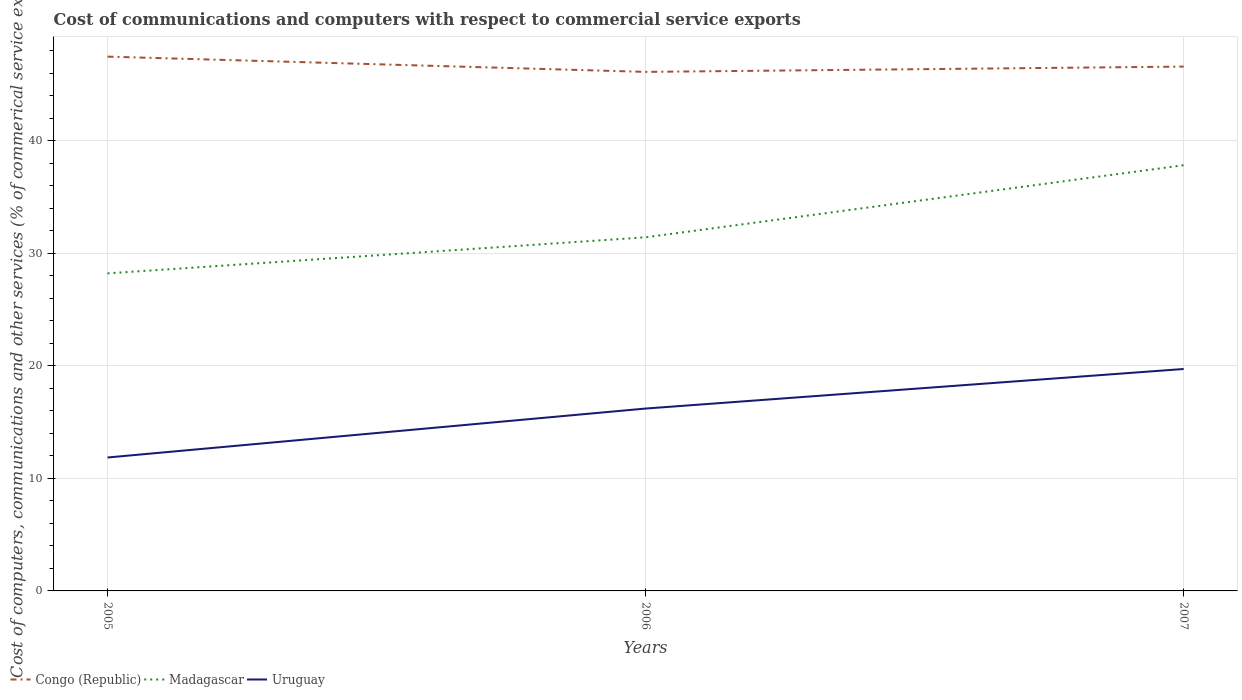Is the number of lines equal to the number of legend labels?
Your answer should be very brief. Yes. Across all years, what is the maximum cost of communications and computers in Congo (Republic)?
Provide a short and direct response. 46.12. In which year was the cost of communications and computers in Congo (Republic) maximum?
Your answer should be compact. 2006. What is the total cost of communications and computers in Congo (Republic) in the graph?
Your answer should be very brief. 0.89. What is the difference between the highest and the second highest cost of communications and computers in Madagascar?
Provide a succinct answer. 9.61. How many years are there in the graph?
Provide a short and direct response. 3. What is the difference between two consecutive major ticks on the Y-axis?
Provide a succinct answer. 10. Does the graph contain any zero values?
Keep it short and to the point. No. Does the graph contain grids?
Give a very brief answer. Yes. What is the title of the graph?
Your response must be concise. Cost of communications and computers with respect to commercial service exports. Does "Liberia" appear as one of the legend labels in the graph?
Ensure brevity in your answer.  No. What is the label or title of the X-axis?
Keep it short and to the point. Years. What is the label or title of the Y-axis?
Provide a succinct answer. Cost of computers, communications and other services (% of commerical service exports). What is the Cost of computers, communications and other services (% of commerical service exports) of Congo (Republic) in 2005?
Your response must be concise. 47.47. What is the Cost of computers, communications and other services (% of commerical service exports) in Madagascar in 2005?
Your response must be concise. 28.21. What is the Cost of computers, communications and other services (% of commerical service exports) of Uruguay in 2005?
Provide a short and direct response. 11.85. What is the Cost of computers, communications and other services (% of commerical service exports) of Congo (Republic) in 2006?
Keep it short and to the point. 46.12. What is the Cost of computers, communications and other services (% of commerical service exports) in Madagascar in 2006?
Your answer should be compact. 31.42. What is the Cost of computers, communications and other services (% of commerical service exports) of Uruguay in 2006?
Your response must be concise. 16.2. What is the Cost of computers, communications and other services (% of commerical service exports) of Congo (Republic) in 2007?
Ensure brevity in your answer.  46.59. What is the Cost of computers, communications and other services (% of commerical service exports) of Madagascar in 2007?
Provide a succinct answer. 37.83. What is the Cost of computers, communications and other services (% of commerical service exports) of Uruguay in 2007?
Ensure brevity in your answer.  19.72. Across all years, what is the maximum Cost of computers, communications and other services (% of commerical service exports) of Congo (Republic)?
Ensure brevity in your answer.  47.47. Across all years, what is the maximum Cost of computers, communications and other services (% of commerical service exports) of Madagascar?
Your response must be concise. 37.83. Across all years, what is the maximum Cost of computers, communications and other services (% of commerical service exports) in Uruguay?
Offer a terse response. 19.72. Across all years, what is the minimum Cost of computers, communications and other services (% of commerical service exports) of Congo (Republic)?
Make the answer very short. 46.12. Across all years, what is the minimum Cost of computers, communications and other services (% of commerical service exports) of Madagascar?
Your answer should be compact. 28.21. Across all years, what is the minimum Cost of computers, communications and other services (% of commerical service exports) of Uruguay?
Give a very brief answer. 11.85. What is the total Cost of computers, communications and other services (% of commerical service exports) in Congo (Republic) in the graph?
Offer a terse response. 140.18. What is the total Cost of computers, communications and other services (% of commerical service exports) in Madagascar in the graph?
Make the answer very short. 97.46. What is the total Cost of computers, communications and other services (% of commerical service exports) of Uruguay in the graph?
Your answer should be very brief. 47.78. What is the difference between the Cost of computers, communications and other services (% of commerical service exports) in Congo (Republic) in 2005 and that in 2006?
Your response must be concise. 1.36. What is the difference between the Cost of computers, communications and other services (% of commerical service exports) in Madagascar in 2005 and that in 2006?
Your answer should be very brief. -3.21. What is the difference between the Cost of computers, communications and other services (% of commerical service exports) in Uruguay in 2005 and that in 2006?
Your answer should be compact. -4.35. What is the difference between the Cost of computers, communications and other services (% of commerical service exports) of Congo (Republic) in 2005 and that in 2007?
Provide a short and direct response. 0.89. What is the difference between the Cost of computers, communications and other services (% of commerical service exports) of Madagascar in 2005 and that in 2007?
Provide a succinct answer. -9.61. What is the difference between the Cost of computers, communications and other services (% of commerical service exports) in Uruguay in 2005 and that in 2007?
Offer a very short reply. -7.87. What is the difference between the Cost of computers, communications and other services (% of commerical service exports) in Congo (Republic) in 2006 and that in 2007?
Give a very brief answer. -0.47. What is the difference between the Cost of computers, communications and other services (% of commerical service exports) in Madagascar in 2006 and that in 2007?
Your answer should be very brief. -6.41. What is the difference between the Cost of computers, communications and other services (% of commerical service exports) of Uruguay in 2006 and that in 2007?
Make the answer very short. -3.52. What is the difference between the Cost of computers, communications and other services (% of commerical service exports) of Congo (Republic) in 2005 and the Cost of computers, communications and other services (% of commerical service exports) of Madagascar in 2006?
Your response must be concise. 16.05. What is the difference between the Cost of computers, communications and other services (% of commerical service exports) of Congo (Republic) in 2005 and the Cost of computers, communications and other services (% of commerical service exports) of Uruguay in 2006?
Ensure brevity in your answer.  31.27. What is the difference between the Cost of computers, communications and other services (% of commerical service exports) in Madagascar in 2005 and the Cost of computers, communications and other services (% of commerical service exports) in Uruguay in 2006?
Keep it short and to the point. 12.01. What is the difference between the Cost of computers, communications and other services (% of commerical service exports) of Congo (Republic) in 2005 and the Cost of computers, communications and other services (% of commerical service exports) of Madagascar in 2007?
Provide a short and direct response. 9.65. What is the difference between the Cost of computers, communications and other services (% of commerical service exports) of Congo (Republic) in 2005 and the Cost of computers, communications and other services (% of commerical service exports) of Uruguay in 2007?
Keep it short and to the point. 27.75. What is the difference between the Cost of computers, communications and other services (% of commerical service exports) in Madagascar in 2005 and the Cost of computers, communications and other services (% of commerical service exports) in Uruguay in 2007?
Keep it short and to the point. 8.49. What is the difference between the Cost of computers, communications and other services (% of commerical service exports) of Congo (Republic) in 2006 and the Cost of computers, communications and other services (% of commerical service exports) of Madagascar in 2007?
Ensure brevity in your answer.  8.29. What is the difference between the Cost of computers, communications and other services (% of commerical service exports) of Congo (Republic) in 2006 and the Cost of computers, communications and other services (% of commerical service exports) of Uruguay in 2007?
Your response must be concise. 26.4. What is the difference between the Cost of computers, communications and other services (% of commerical service exports) in Madagascar in 2006 and the Cost of computers, communications and other services (% of commerical service exports) in Uruguay in 2007?
Ensure brevity in your answer.  11.7. What is the average Cost of computers, communications and other services (% of commerical service exports) of Congo (Republic) per year?
Keep it short and to the point. 46.73. What is the average Cost of computers, communications and other services (% of commerical service exports) of Madagascar per year?
Give a very brief answer. 32.49. What is the average Cost of computers, communications and other services (% of commerical service exports) in Uruguay per year?
Provide a short and direct response. 15.93. In the year 2005, what is the difference between the Cost of computers, communications and other services (% of commerical service exports) in Congo (Republic) and Cost of computers, communications and other services (% of commerical service exports) in Madagascar?
Ensure brevity in your answer.  19.26. In the year 2005, what is the difference between the Cost of computers, communications and other services (% of commerical service exports) of Congo (Republic) and Cost of computers, communications and other services (% of commerical service exports) of Uruguay?
Offer a terse response. 35.62. In the year 2005, what is the difference between the Cost of computers, communications and other services (% of commerical service exports) of Madagascar and Cost of computers, communications and other services (% of commerical service exports) of Uruguay?
Make the answer very short. 16.36. In the year 2006, what is the difference between the Cost of computers, communications and other services (% of commerical service exports) in Congo (Republic) and Cost of computers, communications and other services (% of commerical service exports) in Madagascar?
Give a very brief answer. 14.7. In the year 2006, what is the difference between the Cost of computers, communications and other services (% of commerical service exports) in Congo (Republic) and Cost of computers, communications and other services (% of commerical service exports) in Uruguay?
Provide a succinct answer. 29.91. In the year 2006, what is the difference between the Cost of computers, communications and other services (% of commerical service exports) of Madagascar and Cost of computers, communications and other services (% of commerical service exports) of Uruguay?
Ensure brevity in your answer.  15.22. In the year 2007, what is the difference between the Cost of computers, communications and other services (% of commerical service exports) in Congo (Republic) and Cost of computers, communications and other services (% of commerical service exports) in Madagascar?
Make the answer very short. 8.76. In the year 2007, what is the difference between the Cost of computers, communications and other services (% of commerical service exports) of Congo (Republic) and Cost of computers, communications and other services (% of commerical service exports) of Uruguay?
Offer a terse response. 26.87. In the year 2007, what is the difference between the Cost of computers, communications and other services (% of commerical service exports) of Madagascar and Cost of computers, communications and other services (% of commerical service exports) of Uruguay?
Provide a succinct answer. 18.11. What is the ratio of the Cost of computers, communications and other services (% of commerical service exports) in Congo (Republic) in 2005 to that in 2006?
Make the answer very short. 1.03. What is the ratio of the Cost of computers, communications and other services (% of commerical service exports) in Madagascar in 2005 to that in 2006?
Offer a terse response. 0.9. What is the ratio of the Cost of computers, communications and other services (% of commerical service exports) of Uruguay in 2005 to that in 2006?
Offer a terse response. 0.73. What is the ratio of the Cost of computers, communications and other services (% of commerical service exports) of Congo (Republic) in 2005 to that in 2007?
Provide a short and direct response. 1.02. What is the ratio of the Cost of computers, communications and other services (% of commerical service exports) in Madagascar in 2005 to that in 2007?
Offer a terse response. 0.75. What is the ratio of the Cost of computers, communications and other services (% of commerical service exports) of Uruguay in 2005 to that in 2007?
Give a very brief answer. 0.6. What is the ratio of the Cost of computers, communications and other services (% of commerical service exports) of Congo (Republic) in 2006 to that in 2007?
Provide a succinct answer. 0.99. What is the ratio of the Cost of computers, communications and other services (% of commerical service exports) in Madagascar in 2006 to that in 2007?
Offer a terse response. 0.83. What is the ratio of the Cost of computers, communications and other services (% of commerical service exports) of Uruguay in 2006 to that in 2007?
Your answer should be very brief. 0.82. What is the difference between the highest and the second highest Cost of computers, communications and other services (% of commerical service exports) in Congo (Republic)?
Your answer should be compact. 0.89. What is the difference between the highest and the second highest Cost of computers, communications and other services (% of commerical service exports) in Madagascar?
Ensure brevity in your answer.  6.41. What is the difference between the highest and the second highest Cost of computers, communications and other services (% of commerical service exports) in Uruguay?
Keep it short and to the point. 3.52. What is the difference between the highest and the lowest Cost of computers, communications and other services (% of commerical service exports) in Congo (Republic)?
Give a very brief answer. 1.36. What is the difference between the highest and the lowest Cost of computers, communications and other services (% of commerical service exports) of Madagascar?
Offer a terse response. 9.61. What is the difference between the highest and the lowest Cost of computers, communications and other services (% of commerical service exports) of Uruguay?
Offer a very short reply. 7.87. 